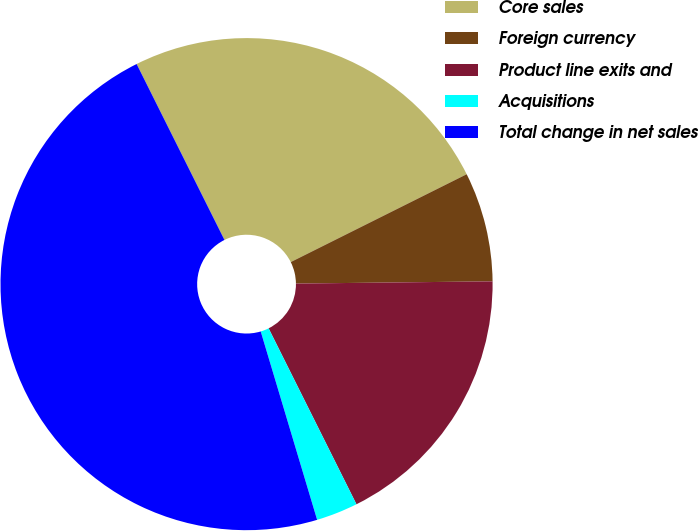<chart> <loc_0><loc_0><loc_500><loc_500><pie_chart><fcel>Core sales<fcel>Foreign currency<fcel>Product line exits and<fcel>Acquisitions<fcel>Total change in net sales<nl><fcel>25.0%<fcel>7.19%<fcel>17.81%<fcel>2.74%<fcel>47.26%<nl></chart> 